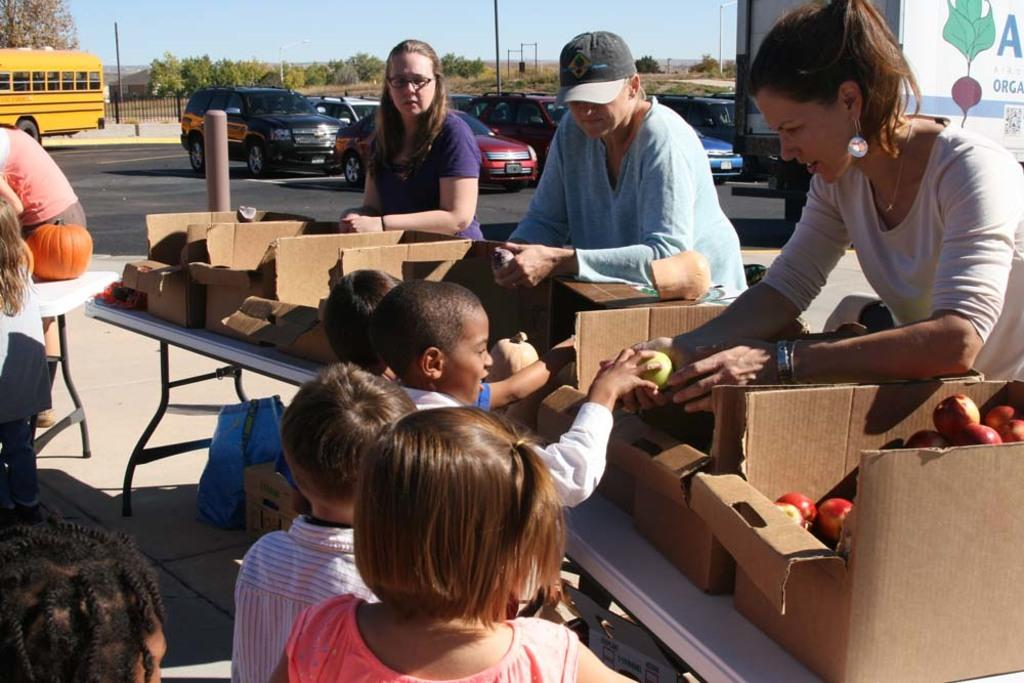How many people are in the image? There are three people in the image. What are the people doing in the image? The people are standing in front of a table. What is on the table in the image? There are fruits on the table. Who is collecting the fruits in the image? There are children collecting the fruits. What can be seen in the background of the image? Cars are visible in the background of the image. What type of market is visible in the image? There is no market present in the image; it features people standing in front of a table with fruits and cars visible in the background. How many trucks are parked in the background of the image? There are no trucks visible in the background of the image; only cars can be seen. 